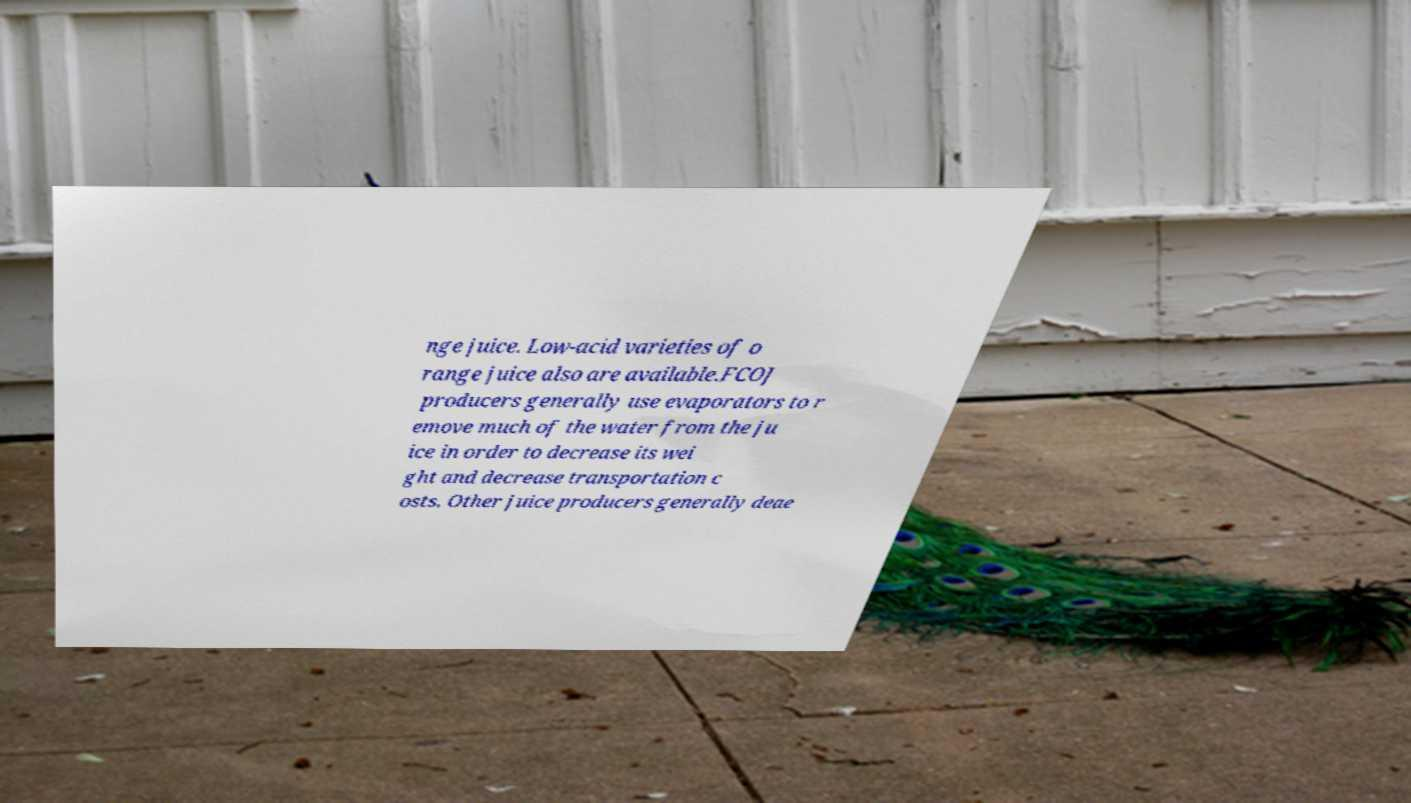Can you accurately transcribe the text from the provided image for me? nge juice. Low-acid varieties of o range juice also are available.FCOJ producers generally use evaporators to r emove much of the water from the ju ice in order to decrease its wei ght and decrease transportation c osts. Other juice producers generally deae 